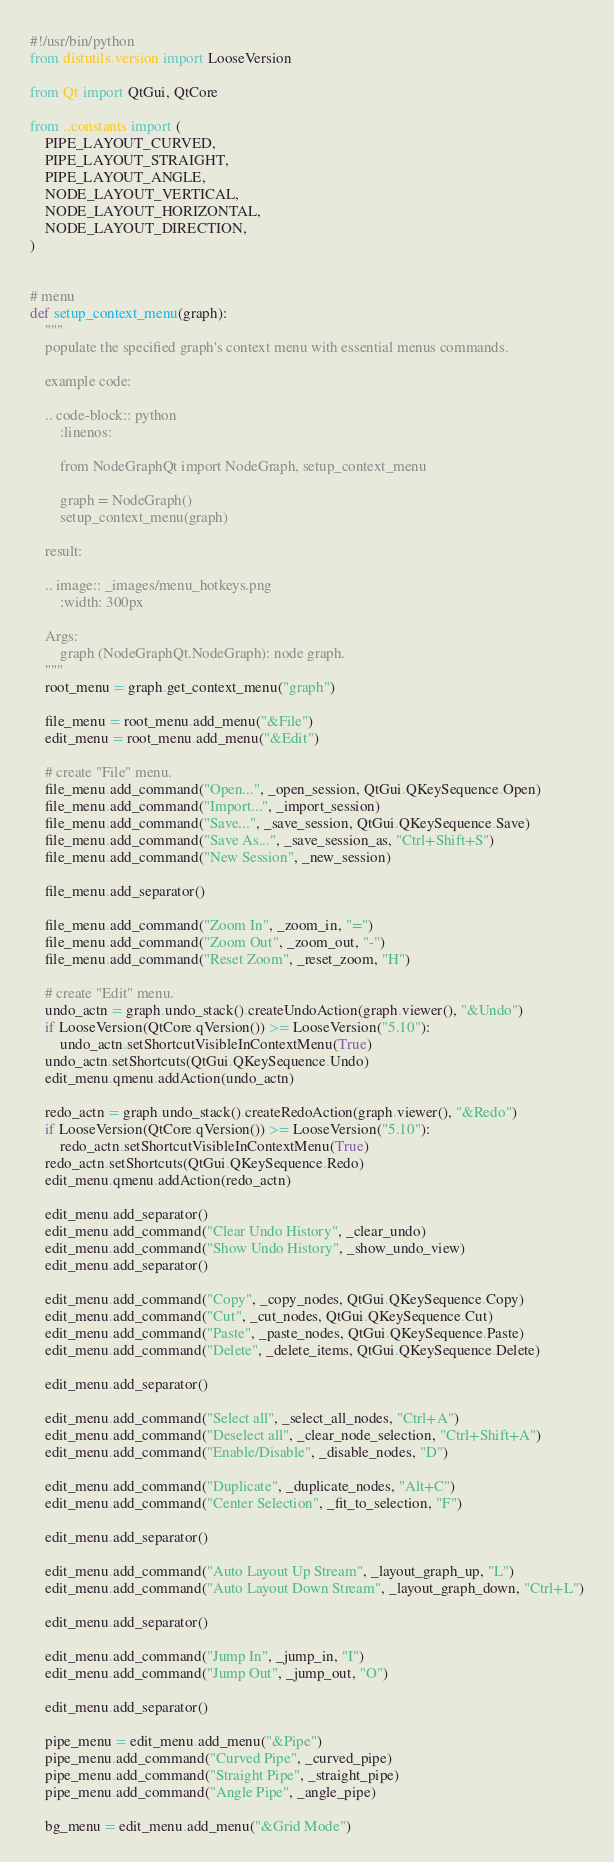<code> <loc_0><loc_0><loc_500><loc_500><_Python_>#!/usr/bin/python
from distutils.version import LooseVersion

from Qt import QtGui, QtCore

from ..constants import (
    PIPE_LAYOUT_CURVED,
    PIPE_LAYOUT_STRAIGHT,
    PIPE_LAYOUT_ANGLE,
    NODE_LAYOUT_VERTICAL,
    NODE_LAYOUT_HORIZONTAL,
    NODE_LAYOUT_DIRECTION,
)


# menu
def setup_context_menu(graph):
    """
    populate the specified graph's context menu with essential menus commands.

    example code:

    .. code-block:: python
        :linenos:

        from NodeGraphQt import NodeGraph, setup_context_menu

        graph = NodeGraph()
        setup_context_menu(graph)

    result:

    .. image:: _images/menu_hotkeys.png
        :width: 300px

    Args:
        graph (NodeGraphQt.NodeGraph): node graph.
    """
    root_menu = graph.get_context_menu("graph")

    file_menu = root_menu.add_menu("&File")
    edit_menu = root_menu.add_menu("&Edit")

    # create "File" menu.
    file_menu.add_command("Open...", _open_session, QtGui.QKeySequence.Open)
    file_menu.add_command("Import...", _import_session)
    file_menu.add_command("Save...", _save_session, QtGui.QKeySequence.Save)
    file_menu.add_command("Save As...", _save_session_as, "Ctrl+Shift+S")
    file_menu.add_command("New Session", _new_session)

    file_menu.add_separator()

    file_menu.add_command("Zoom In", _zoom_in, "=")
    file_menu.add_command("Zoom Out", _zoom_out, "-")
    file_menu.add_command("Reset Zoom", _reset_zoom, "H")

    # create "Edit" menu.
    undo_actn = graph.undo_stack().createUndoAction(graph.viewer(), "&Undo")
    if LooseVersion(QtCore.qVersion()) >= LooseVersion("5.10"):
        undo_actn.setShortcutVisibleInContextMenu(True)
    undo_actn.setShortcuts(QtGui.QKeySequence.Undo)
    edit_menu.qmenu.addAction(undo_actn)

    redo_actn = graph.undo_stack().createRedoAction(graph.viewer(), "&Redo")
    if LooseVersion(QtCore.qVersion()) >= LooseVersion("5.10"):
        redo_actn.setShortcutVisibleInContextMenu(True)
    redo_actn.setShortcuts(QtGui.QKeySequence.Redo)
    edit_menu.qmenu.addAction(redo_actn)

    edit_menu.add_separator()
    edit_menu.add_command("Clear Undo History", _clear_undo)
    edit_menu.add_command("Show Undo History", _show_undo_view)
    edit_menu.add_separator()

    edit_menu.add_command("Copy", _copy_nodes, QtGui.QKeySequence.Copy)
    edit_menu.add_command("Cut", _cut_nodes, QtGui.QKeySequence.Cut)
    edit_menu.add_command("Paste", _paste_nodes, QtGui.QKeySequence.Paste)
    edit_menu.add_command("Delete", _delete_items, QtGui.QKeySequence.Delete)

    edit_menu.add_separator()

    edit_menu.add_command("Select all", _select_all_nodes, "Ctrl+A")
    edit_menu.add_command("Deselect all", _clear_node_selection, "Ctrl+Shift+A")
    edit_menu.add_command("Enable/Disable", _disable_nodes, "D")

    edit_menu.add_command("Duplicate", _duplicate_nodes, "Alt+C")
    edit_menu.add_command("Center Selection", _fit_to_selection, "F")

    edit_menu.add_separator()

    edit_menu.add_command("Auto Layout Up Stream", _layout_graph_up, "L")
    edit_menu.add_command("Auto Layout Down Stream", _layout_graph_down, "Ctrl+L")

    edit_menu.add_separator()

    edit_menu.add_command("Jump In", _jump_in, "I")
    edit_menu.add_command("Jump Out", _jump_out, "O")

    edit_menu.add_separator()

    pipe_menu = edit_menu.add_menu("&Pipe")
    pipe_menu.add_command("Curved Pipe", _curved_pipe)
    pipe_menu.add_command("Straight Pipe", _straight_pipe)
    pipe_menu.add_command("Angle Pipe", _angle_pipe)

    bg_menu = edit_menu.add_menu("&Grid Mode")</code> 